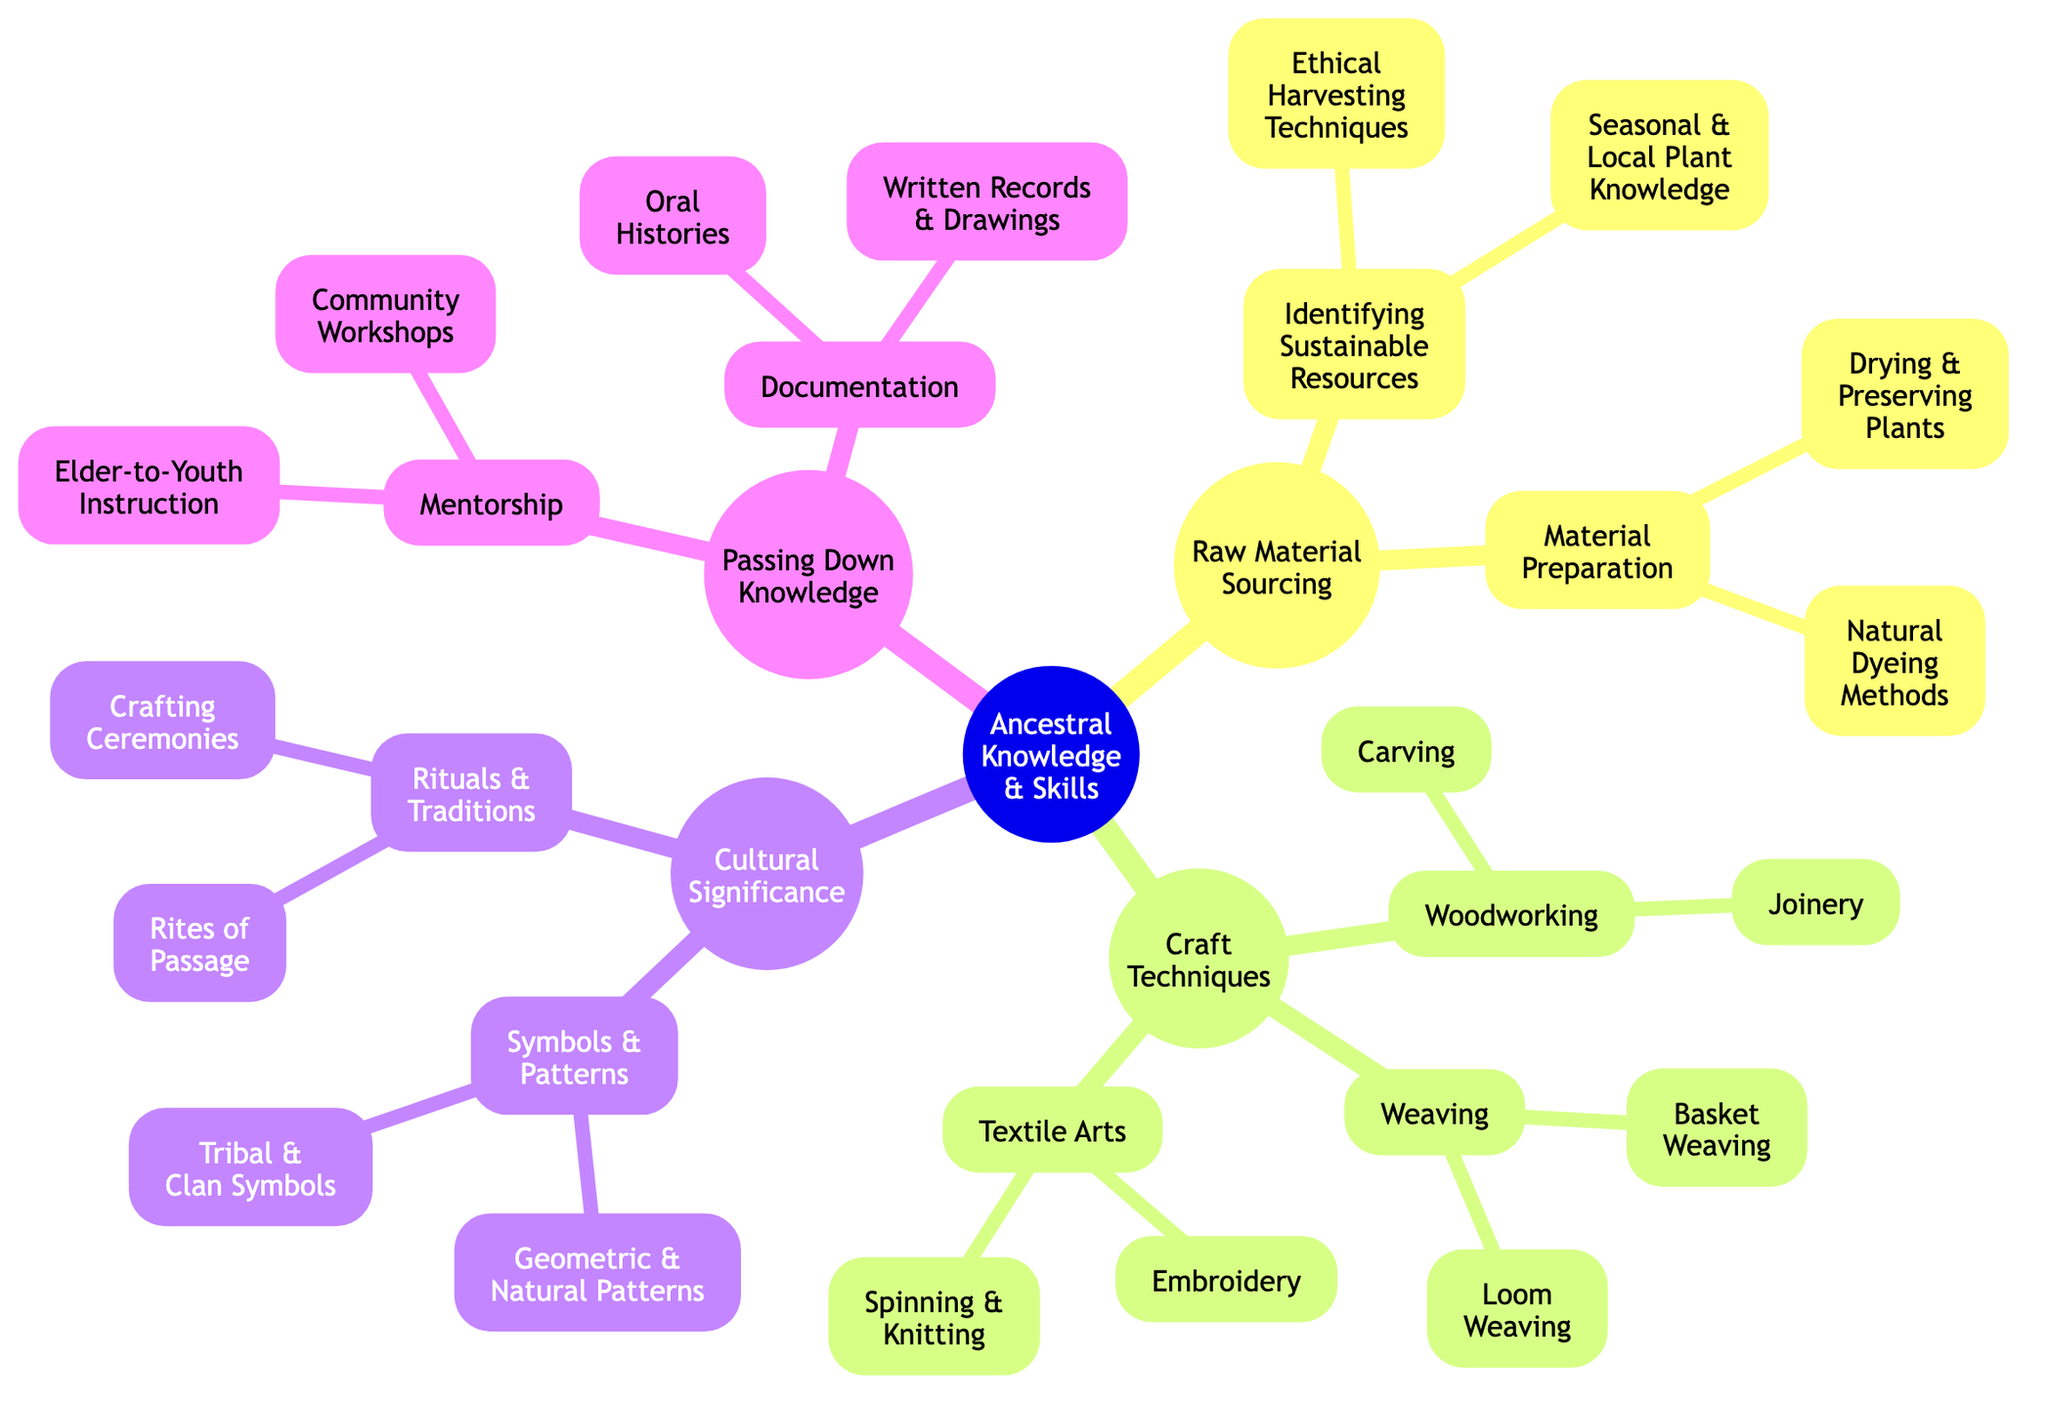What are the two main categories under "Raw Material Sourcing"? The diagram shows that "Raw Material Sourcing" has two main subcategories: "Identifying Sustainable Resources" and "Material Preparation."
Answer: Identifying Sustainable Resources, Material Preparation How many children does "Craft Techniques" have? By examining the diagram, "Craft Techniques" has three children: "Weaving," "Woodworking," and "Textile Arts."
Answer: 3 Which subcategory of "Cultural Significance" focuses on visual representations? The visual representations in "Cultural Significance" are covered under the subcategory "Symbols and Patterns."
Answer: Symbols and Patterns What is the relationship between "Elder-to-Youth Instruction" and "Mentorship"? "Elder-to-Youth Instruction" is a child of "Mentorship," indicating that it is a method of passing down knowledge.
Answer: Mentorship How many total nodes are present in the "Passing Down Knowledge" section? The "Passing Down Knowledge" section consists of two main categories: "Mentorship" (with two children) and "Documentation" (with two children), resulting in four nodes total.
Answer: 4 What are the two methods listed under "Material Preparation"? The diagram indicates that "Material Preparation" includes "Drying and Preserving Plants" and "Natural Dyeing Methods."
Answer: Drying and Preserving Plants, Natural Dyeing Methods Which crafting technique is specifically associated with creating objects from fibers? The crafting technique that involves fibers is "Weaving," which is a primary category under "Craft Techniques."
Answer: Weaving What type of knowledge does "Written Records and Drawings" belong to? "Written Records and Drawings" belong to the "Documentation" category, which is a child of "Passing Down Knowledge."
Answer: Documentation 